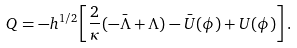Convert formula to latex. <formula><loc_0><loc_0><loc_500><loc_500>Q = - h ^ { 1 / 2 } \left [ \frac { 2 } { \kappa } ( - \bar { \Lambda } + \Lambda ) - \bar { U } ( \phi ) + U ( \phi ) \right ] .</formula> 